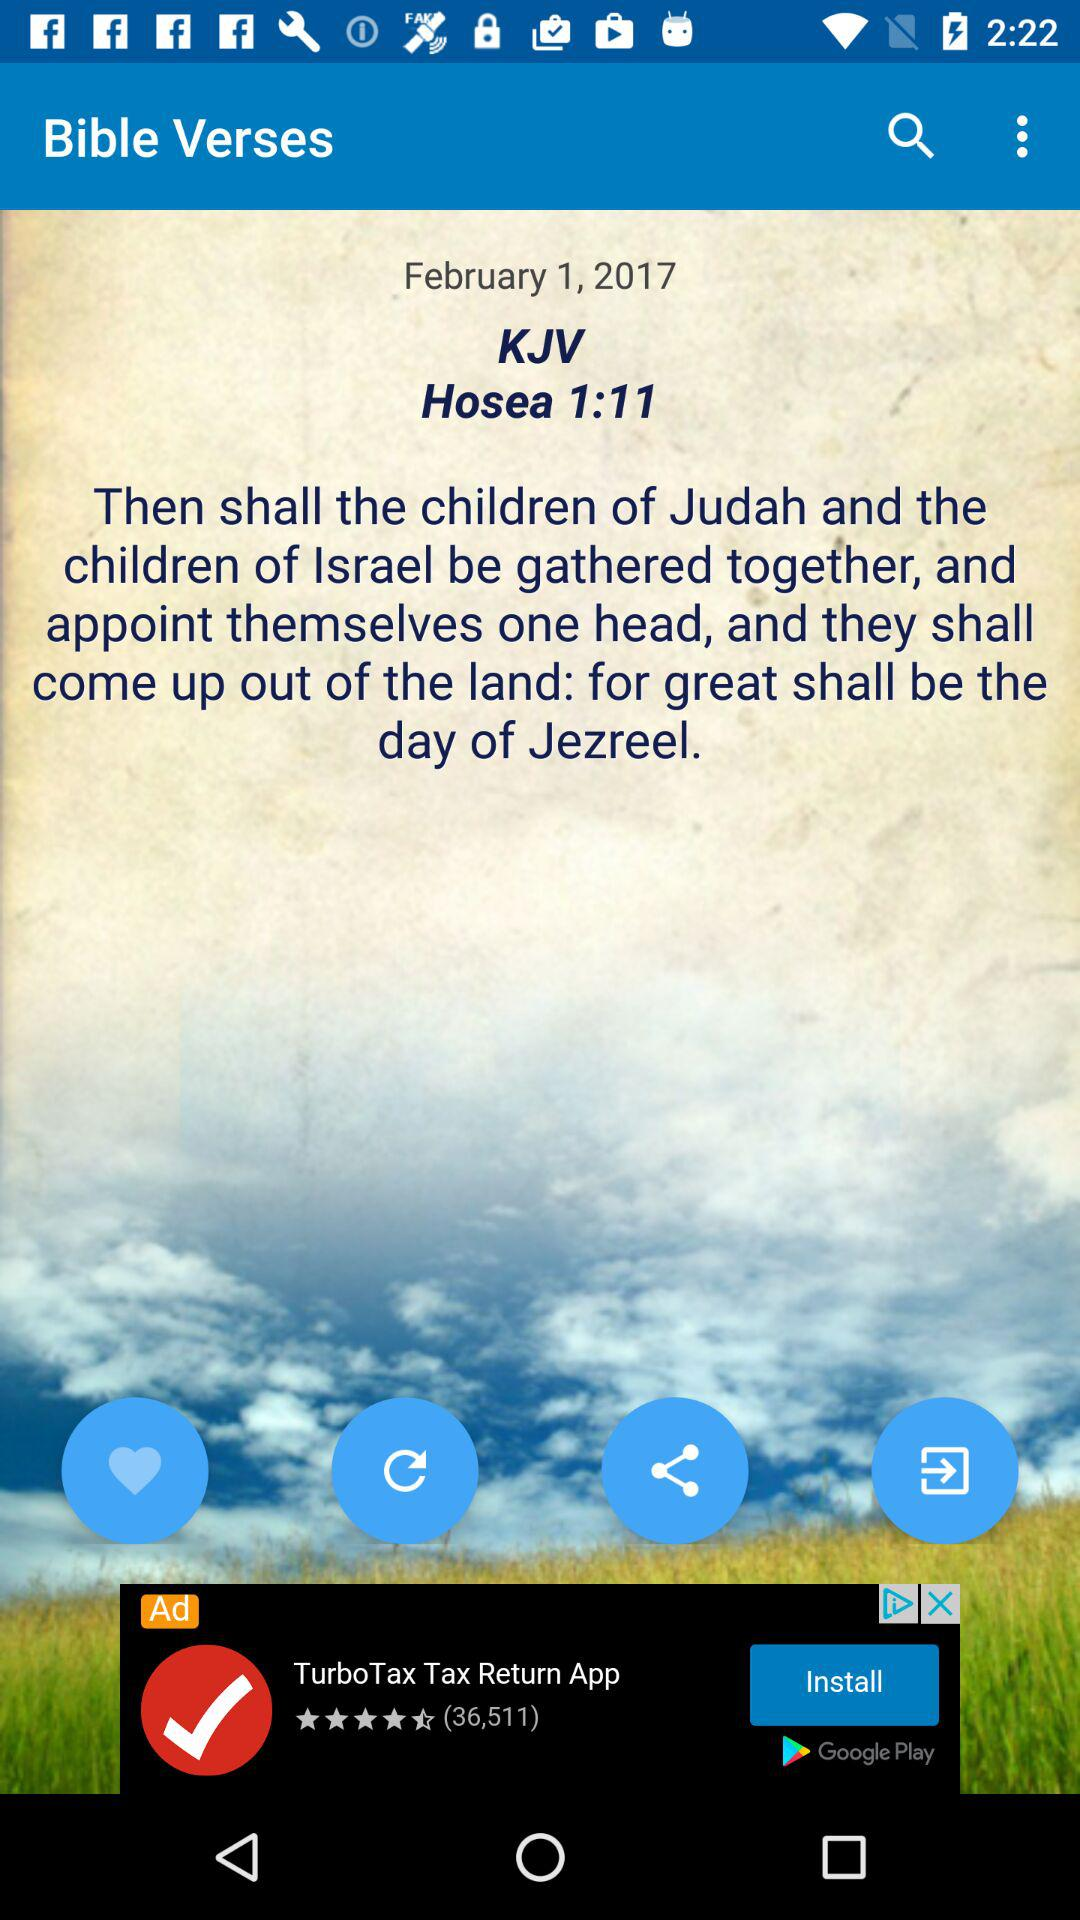Which chapter is open in the Bible verses? The chapter open in the Bible verses is 1. 